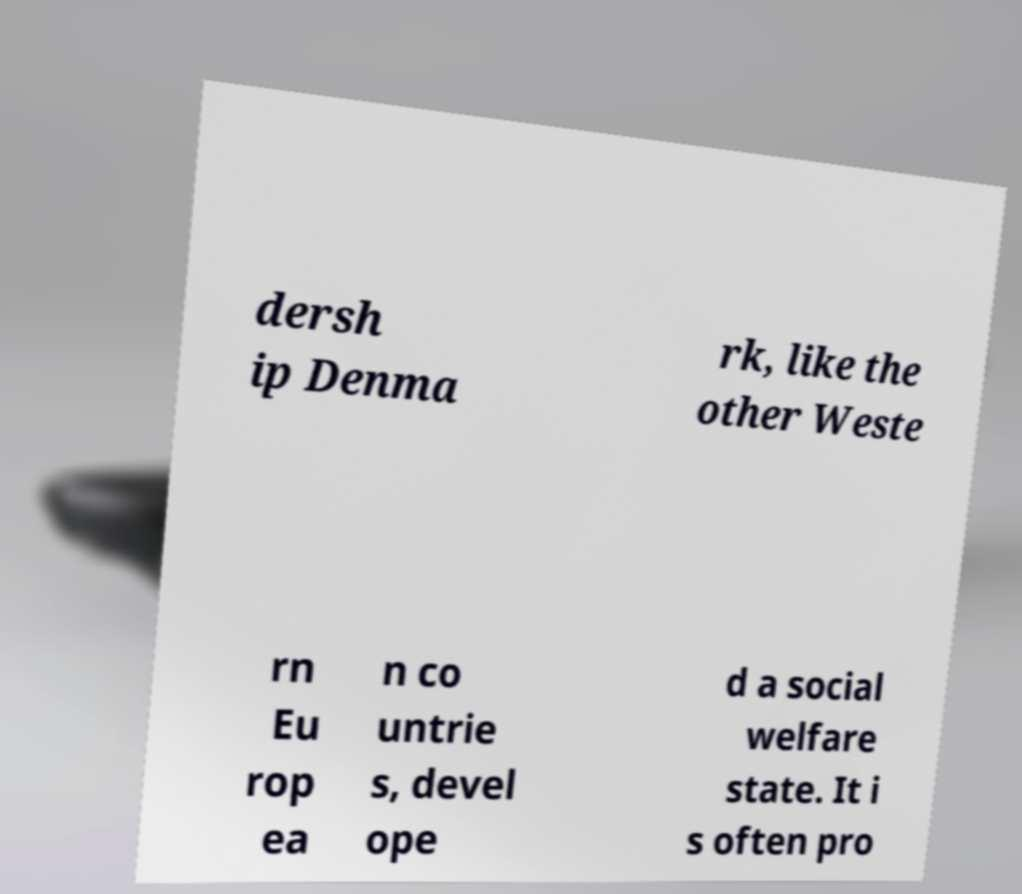Could you assist in decoding the text presented in this image and type it out clearly? dersh ip Denma rk, like the other Weste rn Eu rop ea n co untrie s, devel ope d a social welfare state. It i s often pro 